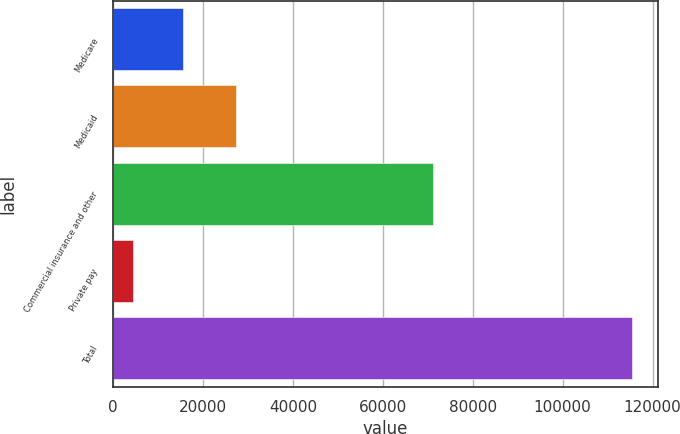Convert chart to OTSL. <chart><loc_0><loc_0><loc_500><loc_500><bar_chart><fcel>Medicare<fcel>Medicaid<fcel>Commercial insurance and other<fcel>Private pay<fcel>Total<nl><fcel>15465.3<fcel>27422<fcel>71191<fcel>4354<fcel>115467<nl></chart> 